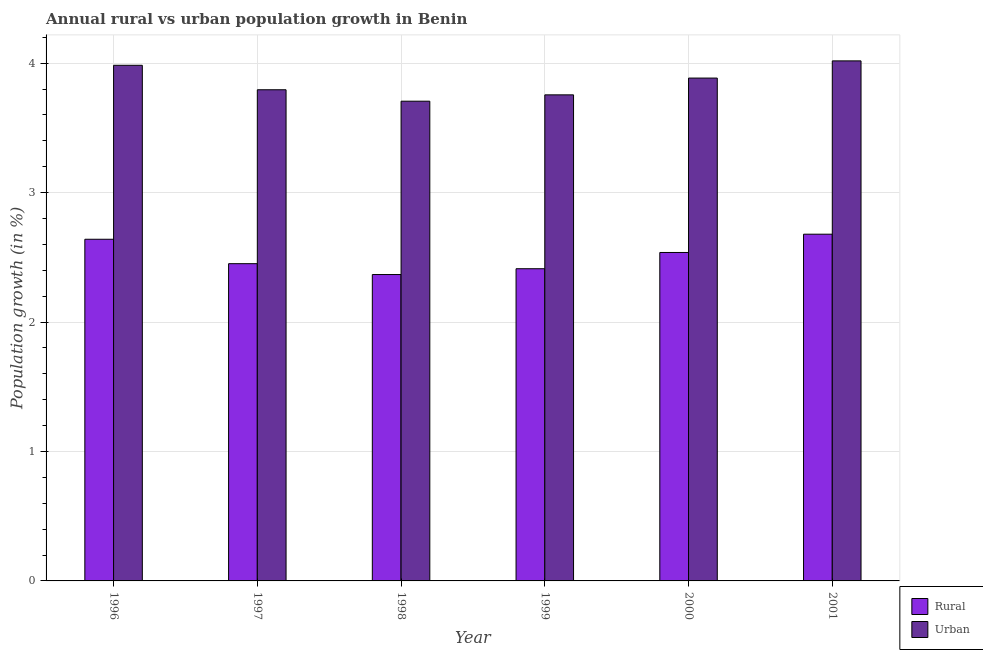How many groups of bars are there?
Offer a very short reply. 6. Are the number of bars per tick equal to the number of legend labels?
Provide a short and direct response. Yes. What is the urban population growth in 1999?
Offer a terse response. 3.76. Across all years, what is the maximum urban population growth?
Ensure brevity in your answer.  4.02. Across all years, what is the minimum rural population growth?
Your answer should be very brief. 2.37. In which year was the rural population growth minimum?
Your answer should be compact. 1998. What is the total urban population growth in the graph?
Offer a very short reply. 23.14. What is the difference between the rural population growth in 1999 and that in 2001?
Keep it short and to the point. -0.27. What is the difference between the urban population growth in 1997 and the rural population growth in 1999?
Keep it short and to the point. 0.04. What is the average urban population growth per year?
Your answer should be compact. 3.86. In how many years, is the rural population growth greater than 3.4 %?
Ensure brevity in your answer.  0. What is the ratio of the rural population growth in 1996 to that in 2000?
Your response must be concise. 1.04. Is the urban population growth in 1996 less than that in 1999?
Your answer should be very brief. No. What is the difference between the highest and the second highest rural population growth?
Your response must be concise. 0.04. What is the difference between the highest and the lowest urban population growth?
Offer a very short reply. 0.31. In how many years, is the urban population growth greater than the average urban population growth taken over all years?
Offer a very short reply. 3. Is the sum of the rural population growth in 1997 and 2001 greater than the maximum urban population growth across all years?
Give a very brief answer. Yes. What does the 1st bar from the left in 1999 represents?
Give a very brief answer. Rural. What does the 2nd bar from the right in 1999 represents?
Offer a very short reply. Rural. How many bars are there?
Offer a terse response. 12. How many years are there in the graph?
Your answer should be compact. 6. What is the difference between two consecutive major ticks on the Y-axis?
Provide a succinct answer. 1. Are the values on the major ticks of Y-axis written in scientific E-notation?
Give a very brief answer. No. Does the graph contain any zero values?
Offer a terse response. No. Does the graph contain grids?
Offer a very short reply. Yes. How many legend labels are there?
Provide a succinct answer. 2. How are the legend labels stacked?
Provide a short and direct response. Vertical. What is the title of the graph?
Offer a very short reply. Annual rural vs urban population growth in Benin. What is the label or title of the X-axis?
Your response must be concise. Year. What is the label or title of the Y-axis?
Ensure brevity in your answer.  Population growth (in %). What is the Population growth (in %) of Rural in 1996?
Provide a succinct answer. 2.64. What is the Population growth (in %) in Urban  in 1996?
Your answer should be compact. 3.98. What is the Population growth (in %) of Rural in 1997?
Offer a terse response. 2.45. What is the Population growth (in %) in Urban  in 1997?
Give a very brief answer. 3.79. What is the Population growth (in %) in Rural in 1998?
Keep it short and to the point. 2.37. What is the Population growth (in %) of Urban  in 1998?
Provide a succinct answer. 3.71. What is the Population growth (in %) in Rural in 1999?
Provide a short and direct response. 2.41. What is the Population growth (in %) in Urban  in 1999?
Provide a short and direct response. 3.76. What is the Population growth (in %) in Rural in 2000?
Offer a very short reply. 2.54. What is the Population growth (in %) in Urban  in 2000?
Ensure brevity in your answer.  3.88. What is the Population growth (in %) of Rural in 2001?
Give a very brief answer. 2.68. What is the Population growth (in %) in Urban  in 2001?
Give a very brief answer. 4.02. Across all years, what is the maximum Population growth (in %) of Rural?
Your answer should be compact. 2.68. Across all years, what is the maximum Population growth (in %) of Urban ?
Provide a succinct answer. 4.02. Across all years, what is the minimum Population growth (in %) of Rural?
Keep it short and to the point. 2.37. Across all years, what is the minimum Population growth (in %) of Urban ?
Provide a short and direct response. 3.71. What is the total Population growth (in %) of Rural in the graph?
Your answer should be compact. 15.09. What is the total Population growth (in %) of Urban  in the graph?
Your answer should be compact. 23.14. What is the difference between the Population growth (in %) in Rural in 1996 and that in 1997?
Keep it short and to the point. 0.19. What is the difference between the Population growth (in %) of Urban  in 1996 and that in 1997?
Provide a succinct answer. 0.19. What is the difference between the Population growth (in %) of Rural in 1996 and that in 1998?
Your response must be concise. 0.27. What is the difference between the Population growth (in %) in Urban  in 1996 and that in 1998?
Ensure brevity in your answer.  0.28. What is the difference between the Population growth (in %) of Rural in 1996 and that in 1999?
Your response must be concise. 0.23. What is the difference between the Population growth (in %) in Urban  in 1996 and that in 1999?
Make the answer very short. 0.23. What is the difference between the Population growth (in %) in Rural in 1996 and that in 2000?
Provide a short and direct response. 0.1. What is the difference between the Population growth (in %) of Urban  in 1996 and that in 2000?
Your response must be concise. 0.1. What is the difference between the Population growth (in %) of Rural in 1996 and that in 2001?
Make the answer very short. -0.04. What is the difference between the Population growth (in %) of Urban  in 1996 and that in 2001?
Keep it short and to the point. -0.03. What is the difference between the Population growth (in %) of Rural in 1997 and that in 1998?
Make the answer very short. 0.08. What is the difference between the Population growth (in %) in Urban  in 1997 and that in 1998?
Provide a short and direct response. 0.09. What is the difference between the Population growth (in %) in Rural in 1997 and that in 1999?
Your answer should be compact. 0.04. What is the difference between the Population growth (in %) of Urban  in 1997 and that in 1999?
Your answer should be very brief. 0.04. What is the difference between the Population growth (in %) in Rural in 1997 and that in 2000?
Offer a very short reply. -0.09. What is the difference between the Population growth (in %) in Urban  in 1997 and that in 2000?
Offer a very short reply. -0.09. What is the difference between the Population growth (in %) of Rural in 1997 and that in 2001?
Offer a very short reply. -0.23. What is the difference between the Population growth (in %) in Urban  in 1997 and that in 2001?
Keep it short and to the point. -0.22. What is the difference between the Population growth (in %) of Rural in 1998 and that in 1999?
Keep it short and to the point. -0.04. What is the difference between the Population growth (in %) of Urban  in 1998 and that in 1999?
Offer a very short reply. -0.05. What is the difference between the Population growth (in %) in Rural in 1998 and that in 2000?
Your response must be concise. -0.17. What is the difference between the Population growth (in %) of Urban  in 1998 and that in 2000?
Offer a terse response. -0.18. What is the difference between the Population growth (in %) in Rural in 1998 and that in 2001?
Your response must be concise. -0.31. What is the difference between the Population growth (in %) of Urban  in 1998 and that in 2001?
Your answer should be compact. -0.31. What is the difference between the Population growth (in %) of Rural in 1999 and that in 2000?
Offer a terse response. -0.13. What is the difference between the Population growth (in %) of Urban  in 1999 and that in 2000?
Provide a short and direct response. -0.13. What is the difference between the Population growth (in %) of Rural in 1999 and that in 2001?
Your answer should be compact. -0.27. What is the difference between the Population growth (in %) of Urban  in 1999 and that in 2001?
Offer a terse response. -0.26. What is the difference between the Population growth (in %) of Rural in 2000 and that in 2001?
Provide a short and direct response. -0.14. What is the difference between the Population growth (in %) in Urban  in 2000 and that in 2001?
Offer a very short reply. -0.13. What is the difference between the Population growth (in %) in Rural in 1996 and the Population growth (in %) in Urban  in 1997?
Offer a very short reply. -1.16. What is the difference between the Population growth (in %) in Rural in 1996 and the Population growth (in %) in Urban  in 1998?
Offer a terse response. -1.07. What is the difference between the Population growth (in %) in Rural in 1996 and the Population growth (in %) in Urban  in 1999?
Offer a very short reply. -1.12. What is the difference between the Population growth (in %) in Rural in 1996 and the Population growth (in %) in Urban  in 2000?
Make the answer very short. -1.25. What is the difference between the Population growth (in %) of Rural in 1996 and the Population growth (in %) of Urban  in 2001?
Offer a terse response. -1.38. What is the difference between the Population growth (in %) in Rural in 1997 and the Population growth (in %) in Urban  in 1998?
Your response must be concise. -1.26. What is the difference between the Population growth (in %) in Rural in 1997 and the Population growth (in %) in Urban  in 1999?
Provide a succinct answer. -1.3. What is the difference between the Population growth (in %) of Rural in 1997 and the Population growth (in %) of Urban  in 2000?
Make the answer very short. -1.43. What is the difference between the Population growth (in %) in Rural in 1997 and the Population growth (in %) in Urban  in 2001?
Your response must be concise. -1.57. What is the difference between the Population growth (in %) in Rural in 1998 and the Population growth (in %) in Urban  in 1999?
Your answer should be very brief. -1.39. What is the difference between the Population growth (in %) of Rural in 1998 and the Population growth (in %) of Urban  in 2000?
Provide a short and direct response. -1.52. What is the difference between the Population growth (in %) in Rural in 1998 and the Population growth (in %) in Urban  in 2001?
Provide a succinct answer. -1.65. What is the difference between the Population growth (in %) of Rural in 1999 and the Population growth (in %) of Urban  in 2000?
Make the answer very short. -1.47. What is the difference between the Population growth (in %) in Rural in 1999 and the Population growth (in %) in Urban  in 2001?
Make the answer very short. -1.61. What is the difference between the Population growth (in %) in Rural in 2000 and the Population growth (in %) in Urban  in 2001?
Ensure brevity in your answer.  -1.48. What is the average Population growth (in %) of Rural per year?
Make the answer very short. 2.51. What is the average Population growth (in %) of Urban  per year?
Keep it short and to the point. 3.86. In the year 1996, what is the difference between the Population growth (in %) in Rural and Population growth (in %) in Urban ?
Give a very brief answer. -1.34. In the year 1997, what is the difference between the Population growth (in %) in Rural and Population growth (in %) in Urban ?
Your answer should be compact. -1.34. In the year 1998, what is the difference between the Population growth (in %) of Rural and Population growth (in %) of Urban ?
Provide a succinct answer. -1.34. In the year 1999, what is the difference between the Population growth (in %) in Rural and Population growth (in %) in Urban ?
Provide a succinct answer. -1.34. In the year 2000, what is the difference between the Population growth (in %) of Rural and Population growth (in %) of Urban ?
Keep it short and to the point. -1.35. In the year 2001, what is the difference between the Population growth (in %) in Rural and Population growth (in %) in Urban ?
Your answer should be very brief. -1.34. What is the ratio of the Population growth (in %) in Urban  in 1996 to that in 1997?
Ensure brevity in your answer.  1.05. What is the ratio of the Population growth (in %) of Rural in 1996 to that in 1998?
Make the answer very short. 1.12. What is the ratio of the Population growth (in %) in Urban  in 1996 to that in 1998?
Keep it short and to the point. 1.07. What is the ratio of the Population growth (in %) in Rural in 1996 to that in 1999?
Offer a very short reply. 1.09. What is the ratio of the Population growth (in %) of Urban  in 1996 to that in 1999?
Your answer should be very brief. 1.06. What is the ratio of the Population growth (in %) of Rural in 1996 to that in 2000?
Your response must be concise. 1.04. What is the ratio of the Population growth (in %) in Urban  in 1996 to that in 2000?
Offer a very short reply. 1.03. What is the ratio of the Population growth (in %) of Rural in 1996 to that in 2001?
Your answer should be very brief. 0.99. What is the ratio of the Population growth (in %) of Rural in 1997 to that in 1998?
Your response must be concise. 1.04. What is the ratio of the Population growth (in %) of Urban  in 1997 to that in 1998?
Your answer should be compact. 1.02. What is the ratio of the Population growth (in %) in Rural in 1997 to that in 1999?
Offer a very short reply. 1.02. What is the ratio of the Population growth (in %) in Urban  in 1997 to that in 1999?
Ensure brevity in your answer.  1.01. What is the ratio of the Population growth (in %) of Rural in 1997 to that in 2000?
Give a very brief answer. 0.97. What is the ratio of the Population growth (in %) in Urban  in 1997 to that in 2000?
Give a very brief answer. 0.98. What is the ratio of the Population growth (in %) of Rural in 1997 to that in 2001?
Your answer should be very brief. 0.92. What is the ratio of the Population growth (in %) in Urban  in 1997 to that in 2001?
Your answer should be very brief. 0.94. What is the ratio of the Population growth (in %) of Rural in 1998 to that in 1999?
Offer a terse response. 0.98. What is the ratio of the Population growth (in %) of Urban  in 1998 to that in 1999?
Your response must be concise. 0.99. What is the ratio of the Population growth (in %) in Rural in 1998 to that in 2000?
Provide a short and direct response. 0.93. What is the ratio of the Population growth (in %) of Urban  in 1998 to that in 2000?
Give a very brief answer. 0.95. What is the ratio of the Population growth (in %) of Rural in 1998 to that in 2001?
Offer a very short reply. 0.88. What is the ratio of the Population growth (in %) in Urban  in 1998 to that in 2001?
Offer a terse response. 0.92. What is the ratio of the Population growth (in %) in Rural in 1999 to that in 2000?
Offer a very short reply. 0.95. What is the ratio of the Population growth (in %) in Urban  in 1999 to that in 2000?
Your answer should be compact. 0.97. What is the ratio of the Population growth (in %) in Rural in 1999 to that in 2001?
Offer a terse response. 0.9. What is the ratio of the Population growth (in %) in Urban  in 1999 to that in 2001?
Keep it short and to the point. 0.93. What is the ratio of the Population growth (in %) in Rural in 2000 to that in 2001?
Offer a very short reply. 0.95. What is the ratio of the Population growth (in %) in Urban  in 2000 to that in 2001?
Provide a short and direct response. 0.97. What is the difference between the highest and the second highest Population growth (in %) of Rural?
Offer a very short reply. 0.04. What is the difference between the highest and the second highest Population growth (in %) of Urban ?
Make the answer very short. 0.03. What is the difference between the highest and the lowest Population growth (in %) in Rural?
Offer a very short reply. 0.31. What is the difference between the highest and the lowest Population growth (in %) of Urban ?
Make the answer very short. 0.31. 